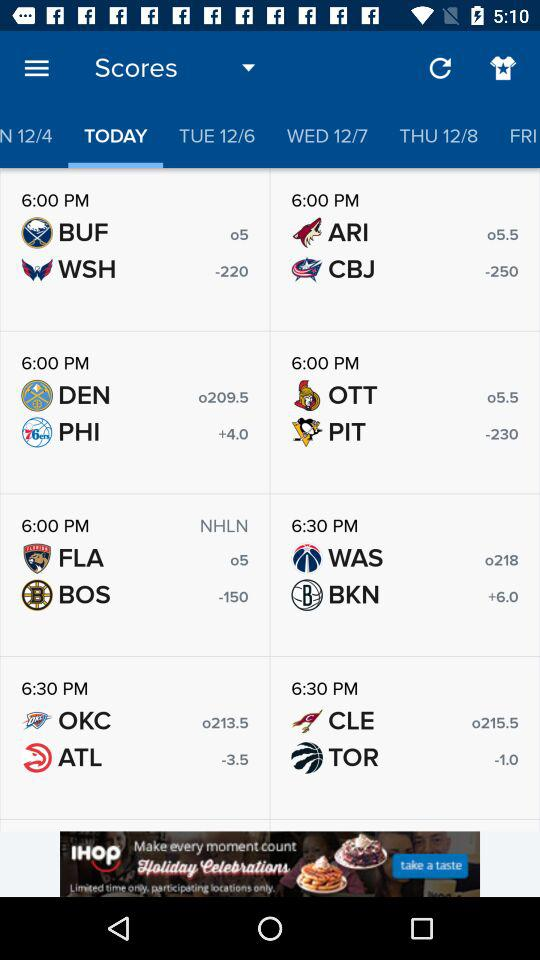What is the score of WAS and BKN? The scores of WAS and BKN are o218 and +6.0, respectively. 